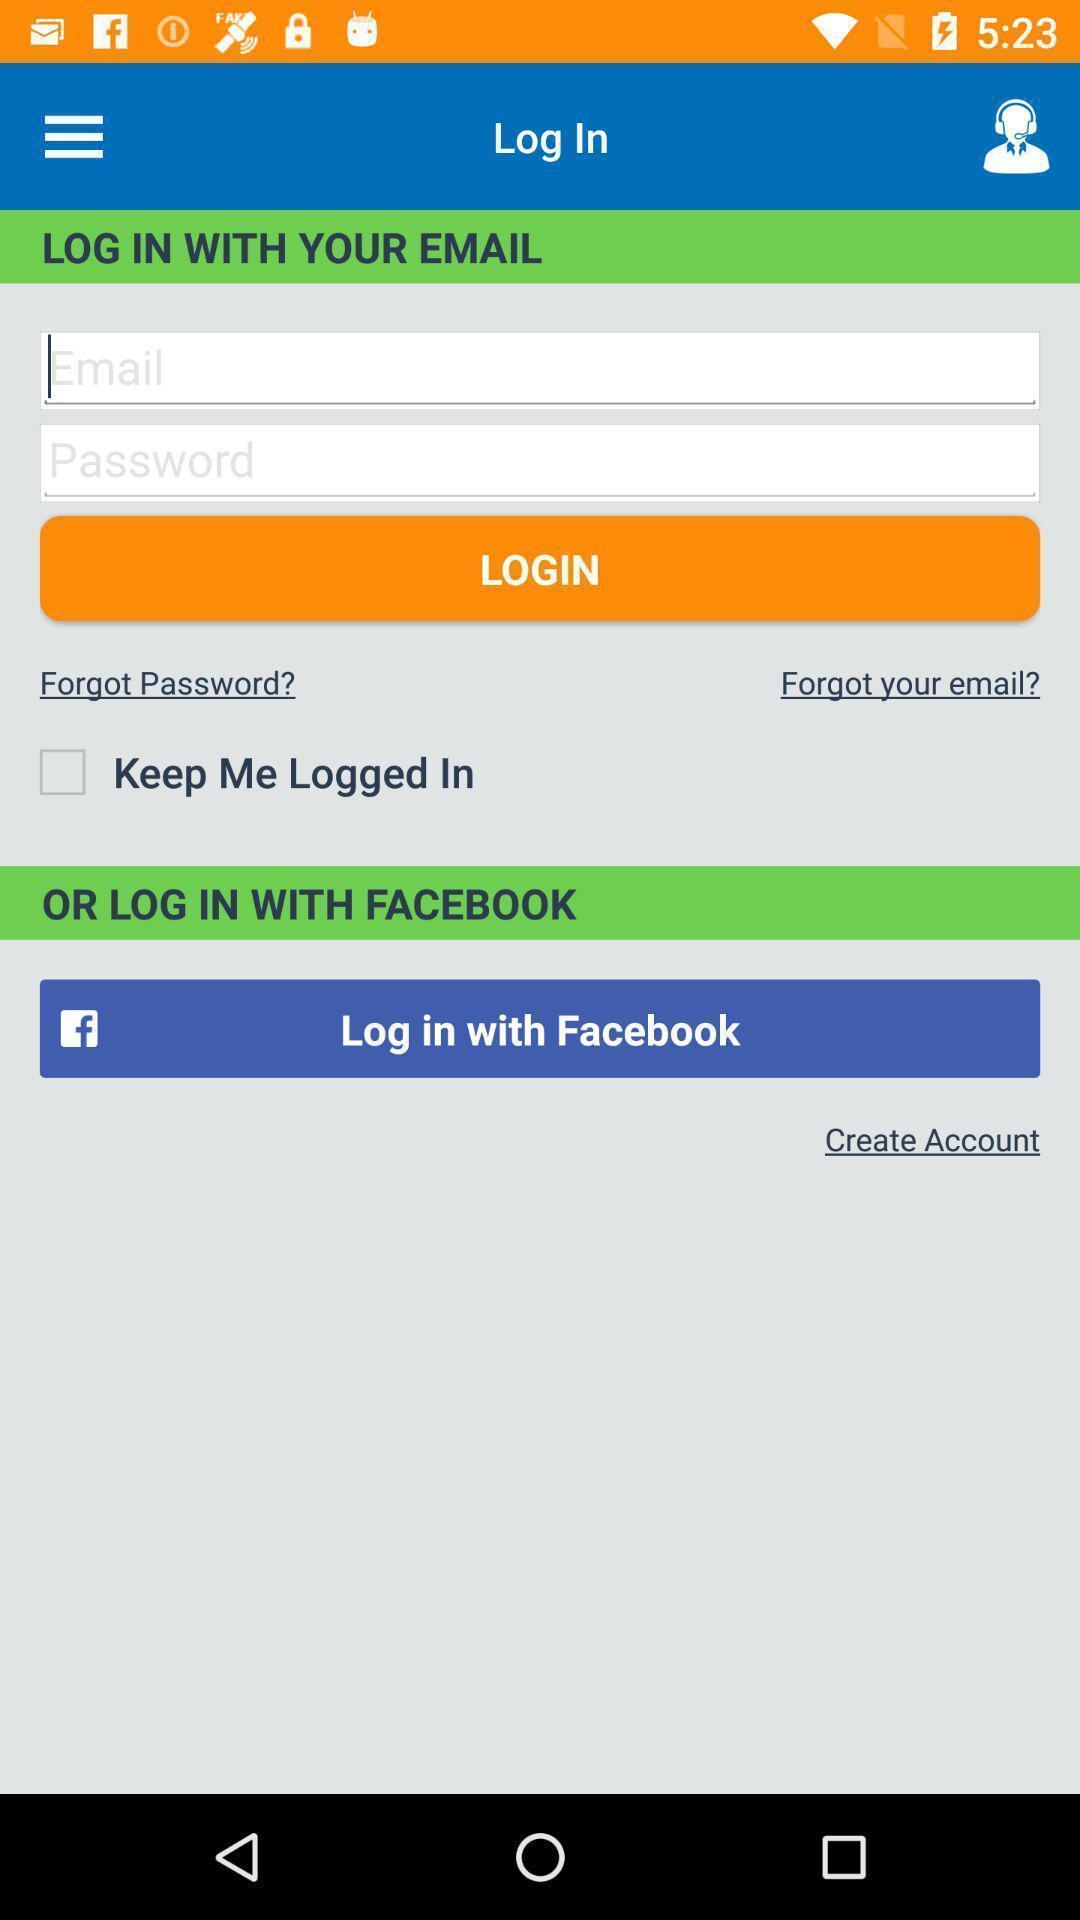Summarize the information in this screenshot. Welcome to the login page. 